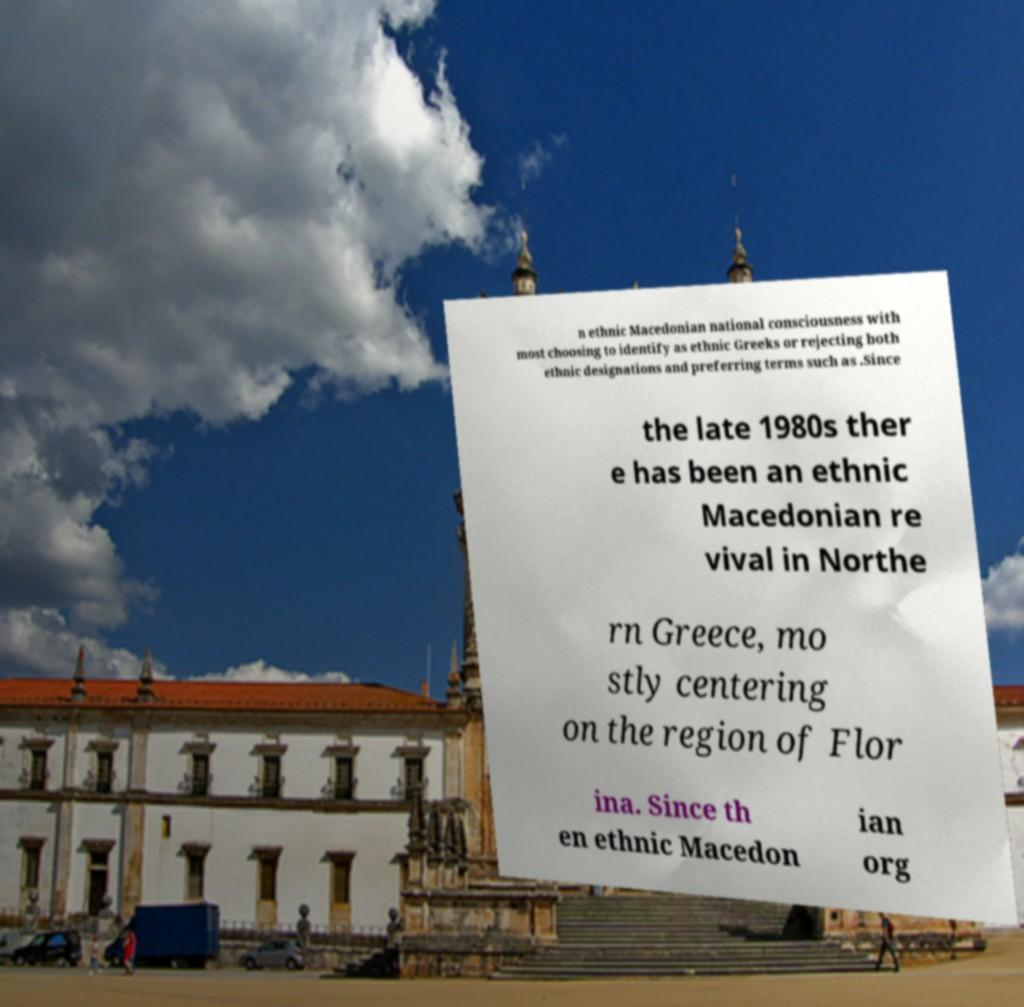What messages or text are displayed in this image? I need them in a readable, typed format. n ethnic Macedonian national consciousness with most choosing to identify as ethnic Greeks or rejecting both ethnic designations and preferring terms such as .Since the late 1980s ther e has been an ethnic Macedonian re vival in Northe rn Greece, mo stly centering on the region of Flor ina. Since th en ethnic Macedon ian org 